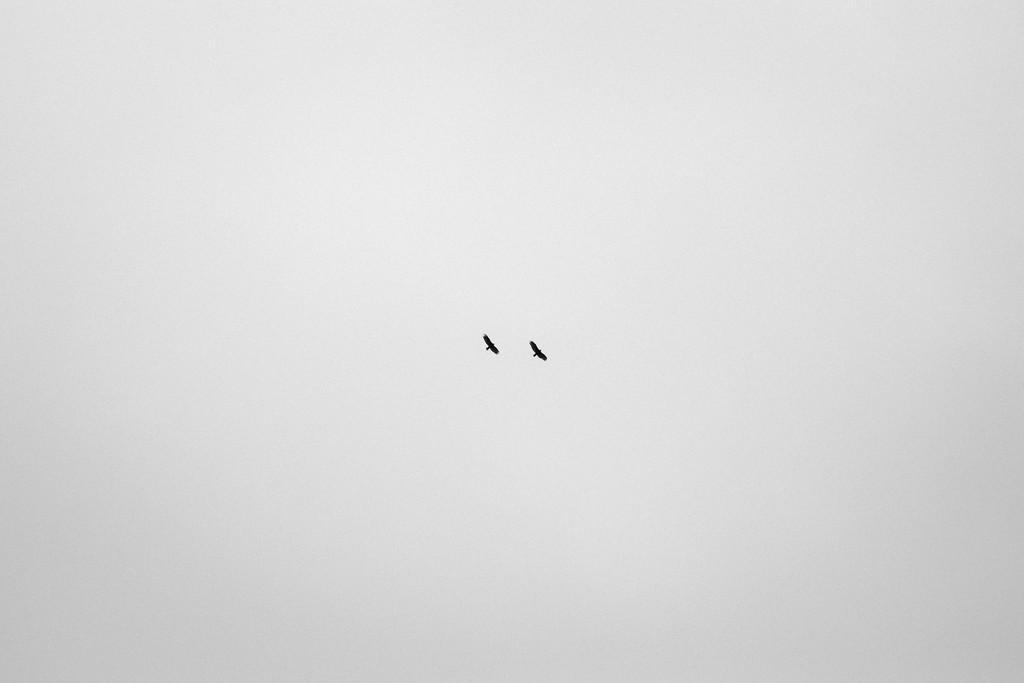How would you summarize this image in a sentence or two? These are the 2 birds that are flying in the sky. 